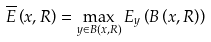<formula> <loc_0><loc_0><loc_500><loc_500>\overline { E } \left ( x , R \right ) = \max _ { y \in B \left ( x , R \right ) } E _ { y } \left ( B \left ( x , R \right ) \right )</formula> 